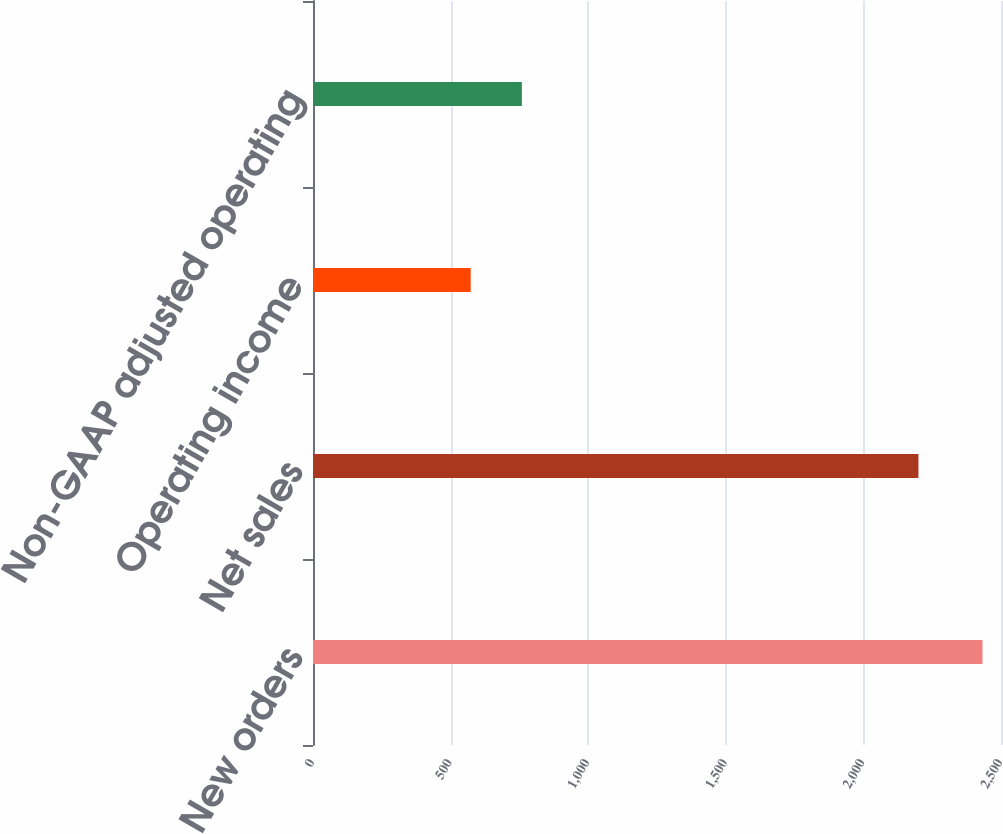Convert chart. <chart><loc_0><loc_0><loc_500><loc_500><bar_chart><fcel>New orders<fcel>Net sales<fcel>Operating income<fcel>Non-GAAP adjusted operating<nl><fcel>2433<fcel>2200<fcel>573<fcel>759<nl></chart> 